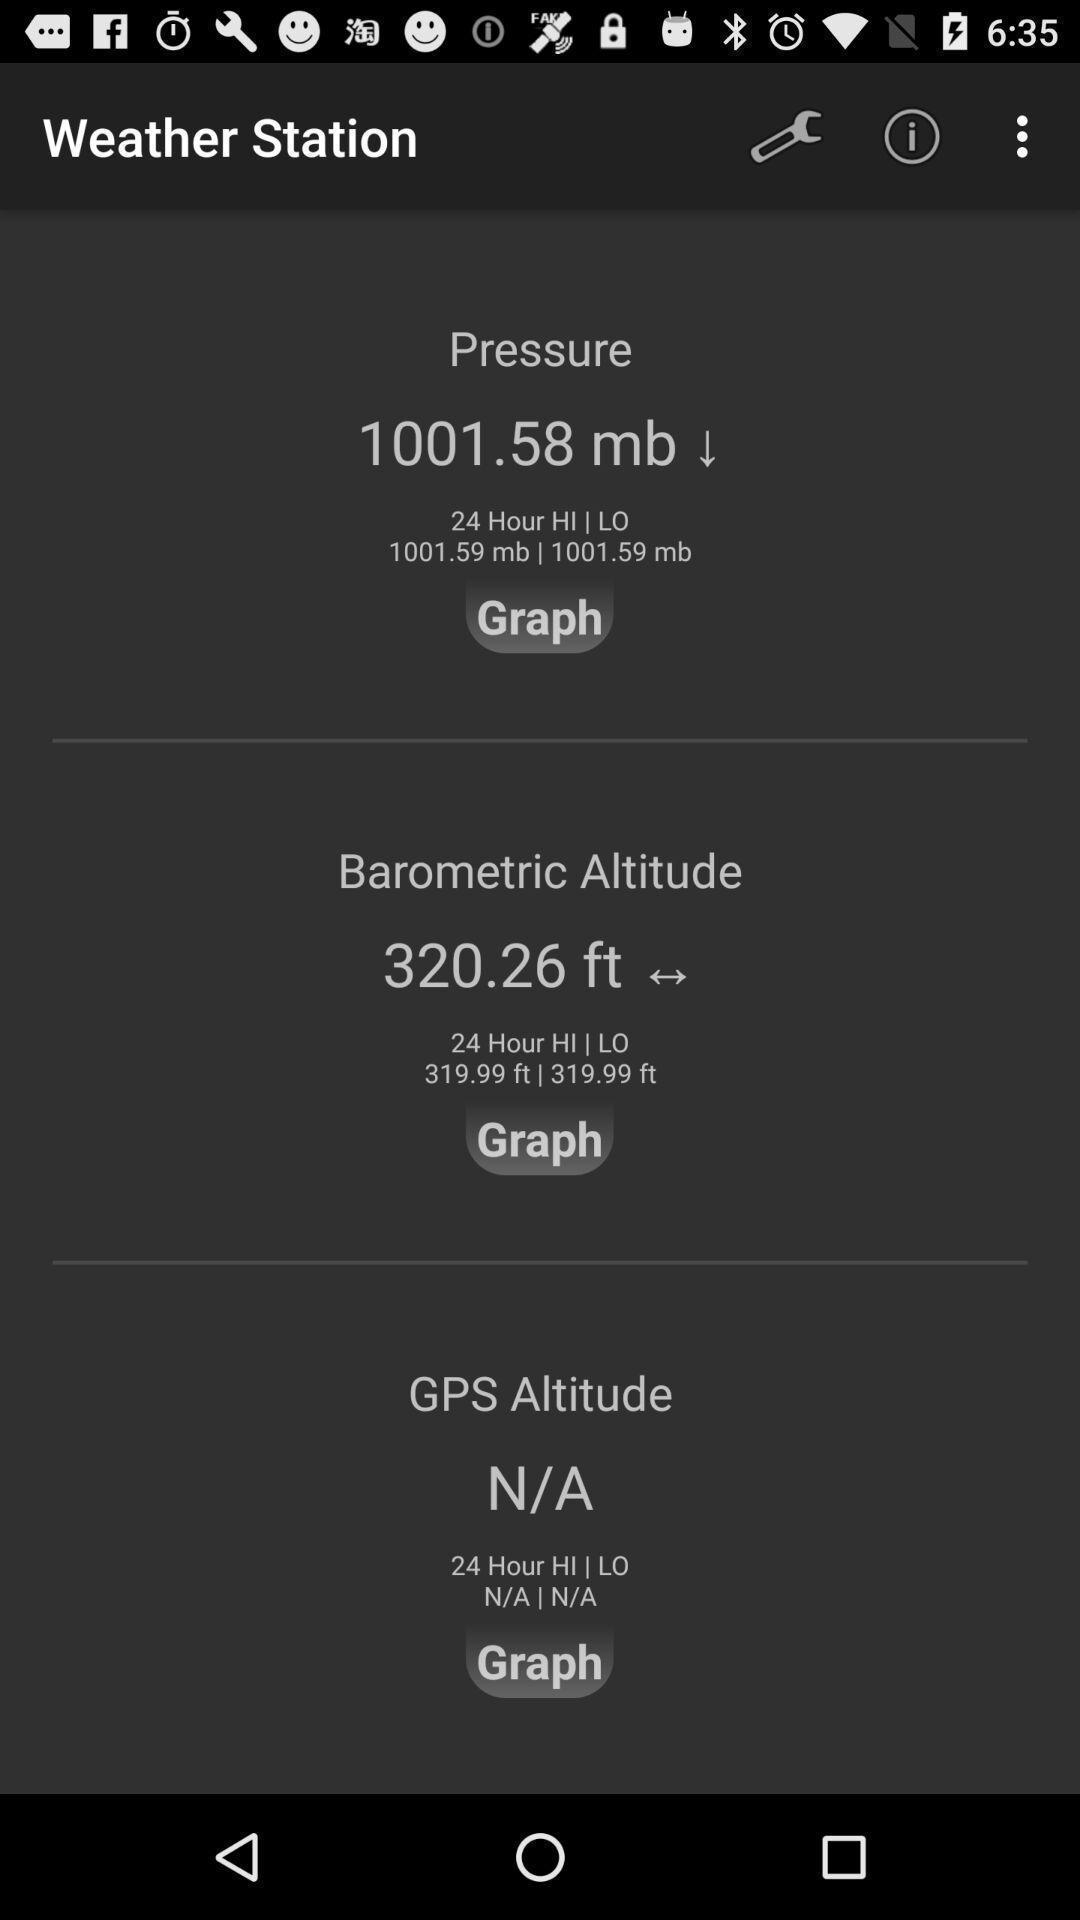Tell me what you see in this picture. Screen shows weather station information. 